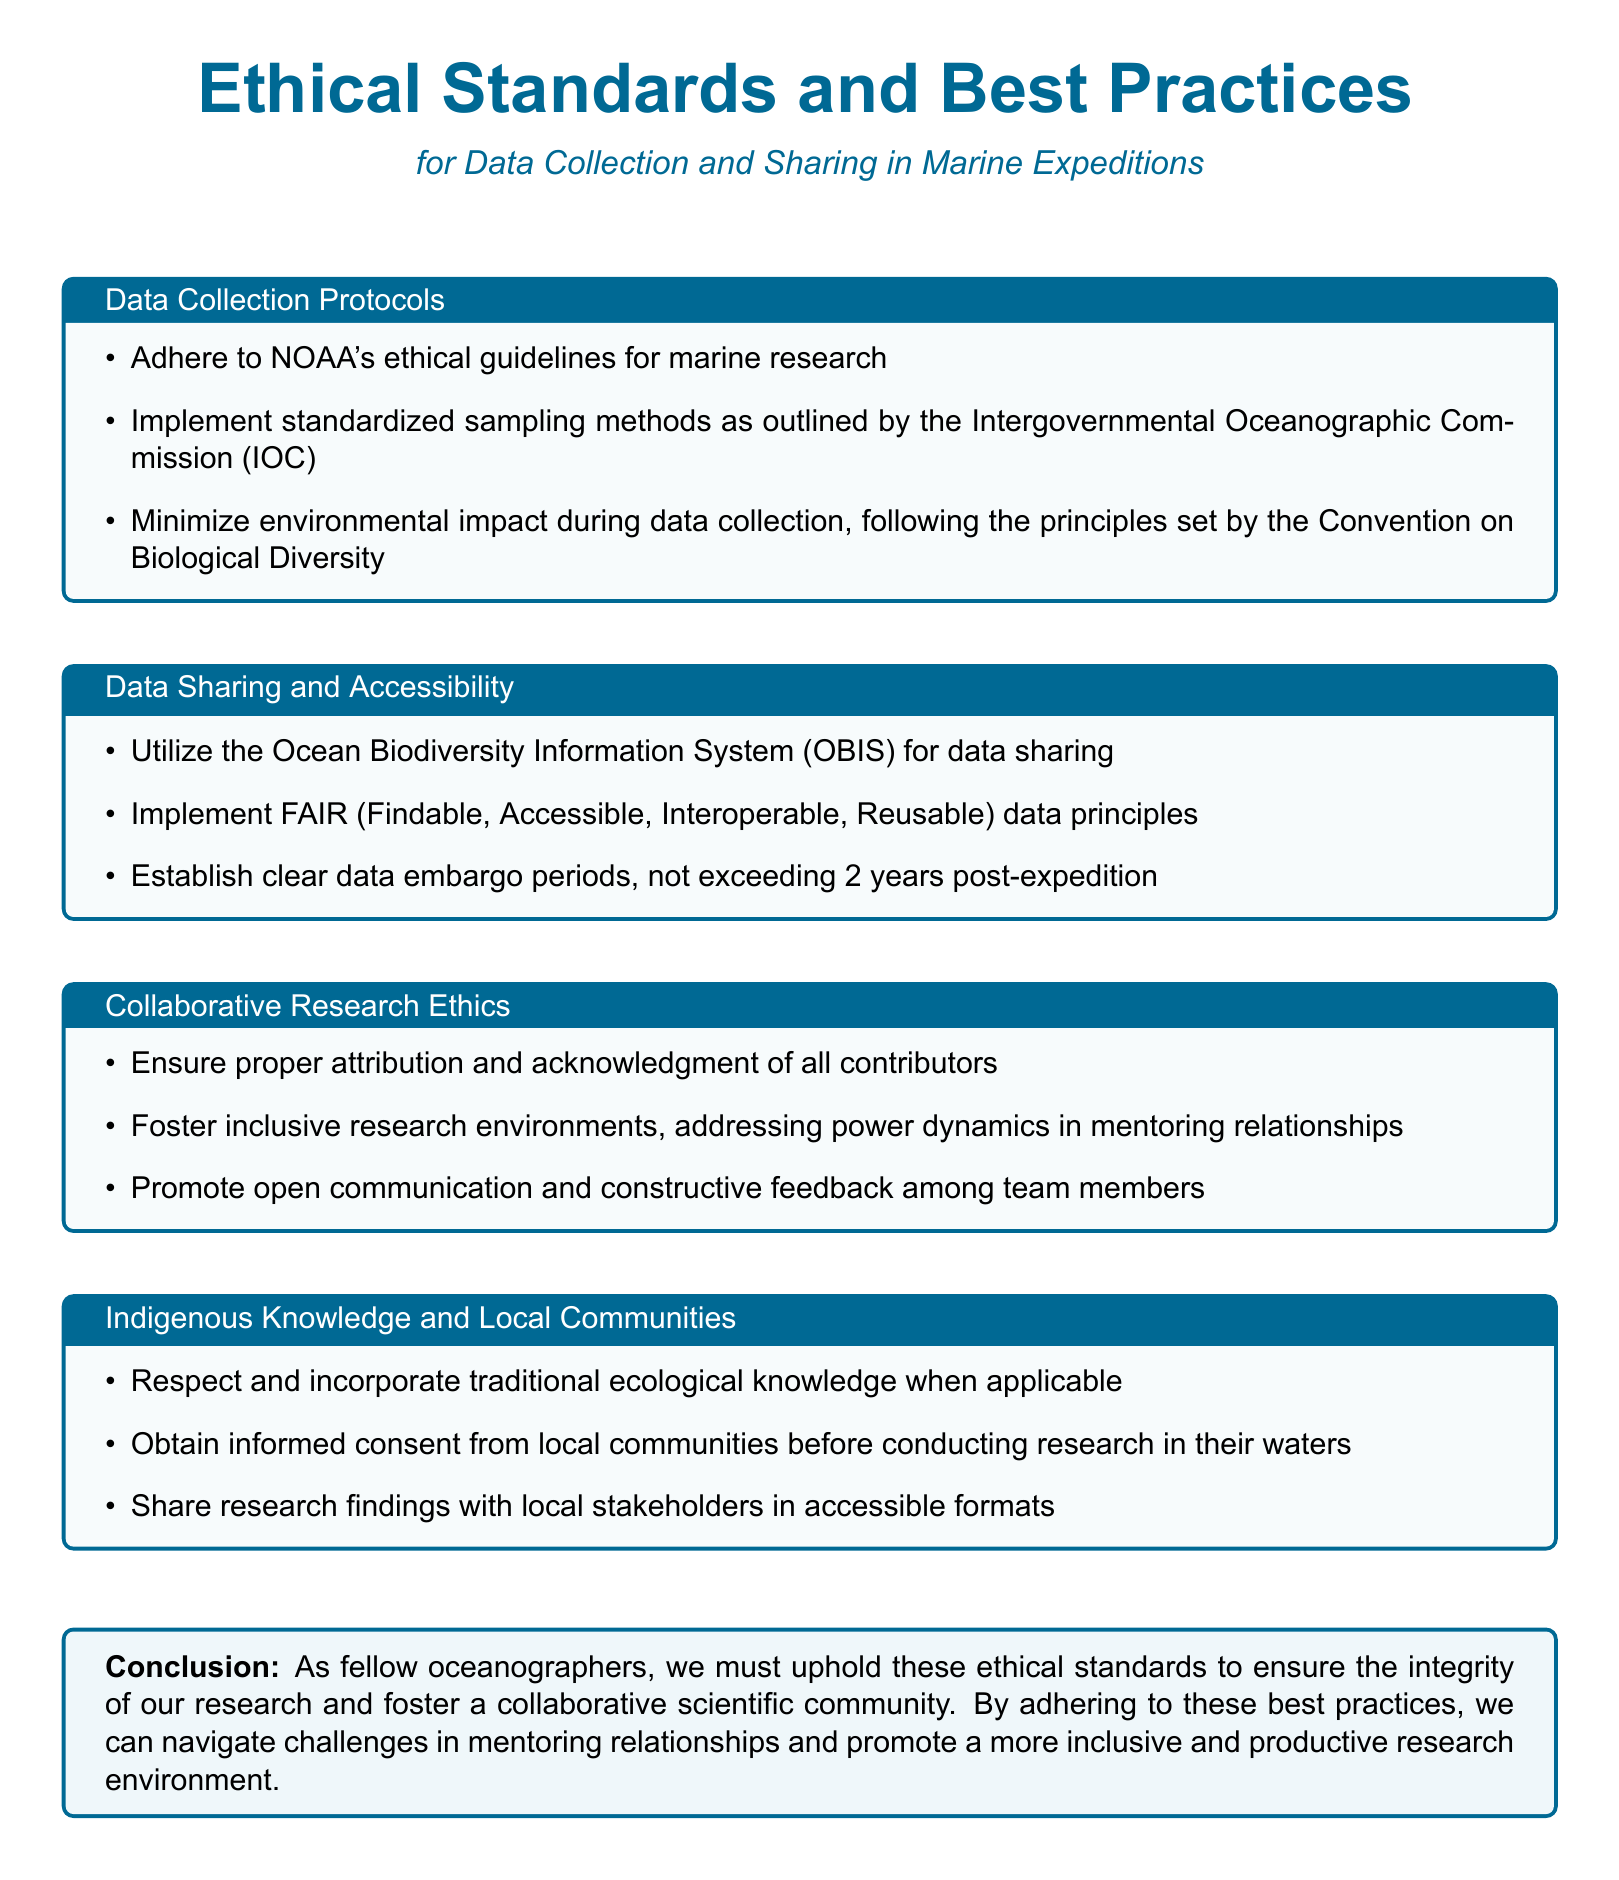What are the ethical guidelines that should be adhered to during marine research? The document states that NOAA's ethical guidelines for marine research should be adhered to.
Answer: NOAA's ethical guidelines What sampling methods should be implemented according to the IOC? The document indicates that standardized sampling methods outlined by the Intergovernmental Oceanographic Commission (IOC) should be implemented.
Answer: Standardized sampling methods What is the maximum data embargo period after an expedition? The document specifies that the data embargo period should not exceed 2 years post-expedition.
Answer: 2 years What system is recommended for data sharing? The document mentions the Ocean Biodiversity Information System (OBIS) as a recommended system for data sharing.
Answer: Ocean Biodiversity Information System What principle should be followed for data accessibility? The document states that FAIR (Findable, Accessible, Interoperable, Reusable) data principles should be implemented for data accessibility.
Answer: FAIR How should traditional ecological knowledge be treated? The document advises that traditional ecological knowledge should be respected and incorporated when applicable.
Answer: Respected and incorporated What is emphasized regarding contributions in collaborative research? The document emphasizes that proper attribution and acknowledgment of all contributors are essential in collaborative research.
Answer: Proper attribution What should be shared with local stakeholders? The document suggests that research findings should be shared with local stakeholders in accessible formats.
Answer: Research findings What is the conclusion statement aiming to foster in the scientific community? The conclusion aims to foster a collaborative scientific community by upholding ethical standards and best practices.
Answer: Collaborative scientific community 